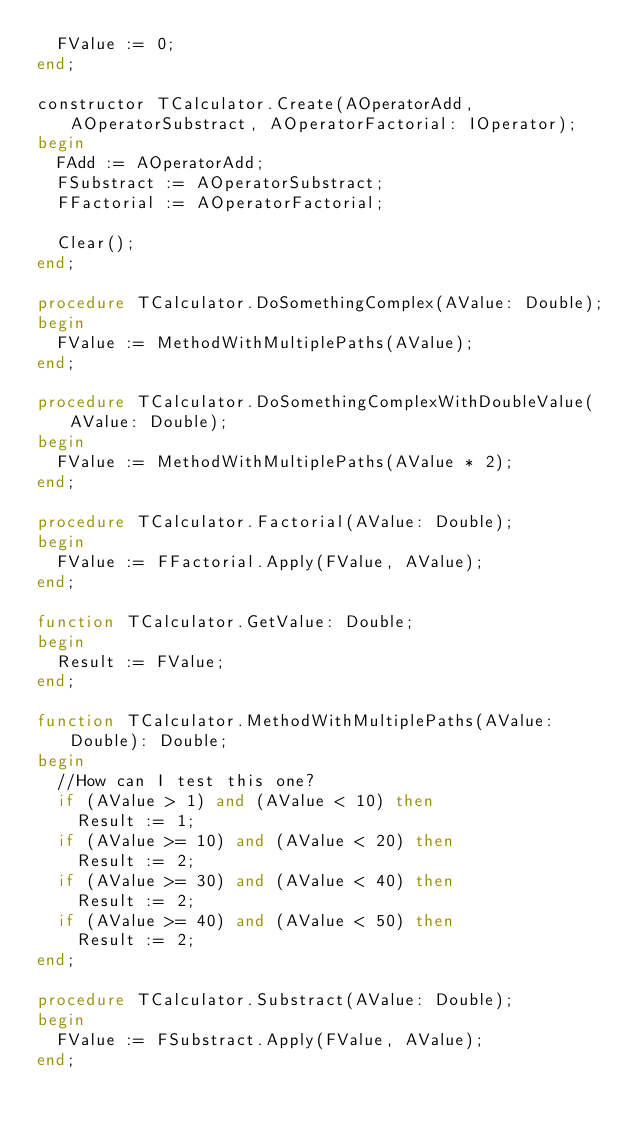Convert code to text. <code><loc_0><loc_0><loc_500><loc_500><_Pascal_>  FValue := 0;
end;

constructor TCalculator.Create(AOperatorAdd, AOperatorSubstract, AOperatorFactorial: IOperator);
begin
  FAdd := AOperatorAdd;
  FSubstract := AOperatorSubstract;
  FFactorial := AOperatorFactorial;

  Clear();
end;

procedure TCalculator.DoSomethingComplex(AValue: Double);
begin
  FValue := MethodWithMultiplePaths(AValue);
end;

procedure TCalculator.DoSomethingComplexWithDoubleValue(AValue: Double);
begin
  FValue := MethodWithMultiplePaths(AValue * 2);
end;

procedure TCalculator.Factorial(AValue: Double);
begin
  FValue := FFactorial.Apply(FValue, AValue);
end;

function TCalculator.GetValue: Double;
begin
  Result := FValue;
end;

function TCalculator.MethodWithMultiplePaths(AValue: Double): Double;
begin
  //How can I test this one?
  if (AValue > 1) and (AValue < 10) then
    Result := 1;
  if (AValue >= 10) and (AValue < 20) then
    Result := 2;
  if (AValue >= 30) and (AValue < 40) then
    Result := 2;
  if (AValue >= 40) and (AValue < 50) then
    Result := 2;
end;

procedure TCalculator.Substract(AValue: Double);
begin
  FValue := FSubstract.Apply(FValue, AValue);
end;
</code> 